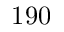<formula> <loc_0><loc_0><loc_500><loc_500>1 9 0</formula> 